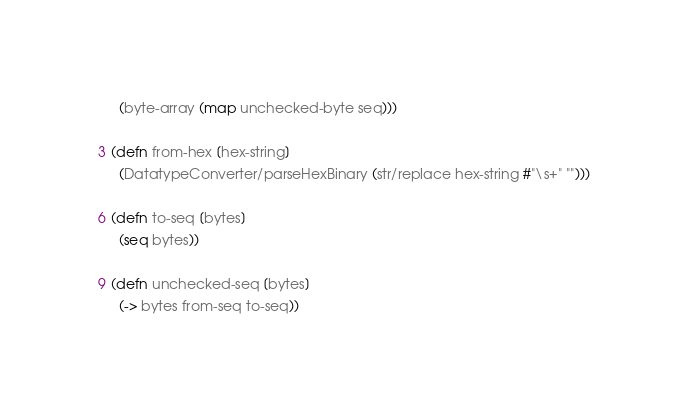<code> <loc_0><loc_0><loc_500><loc_500><_Clojure_>  (byte-array (map unchecked-byte seq)))

(defn from-hex [hex-string]
  (DatatypeConverter/parseHexBinary (str/replace hex-string #"\s+" "")))

(defn to-seq [bytes]
  (seq bytes))

(defn unchecked-seq [bytes]
  (-> bytes from-seq to-seq))
</code> 